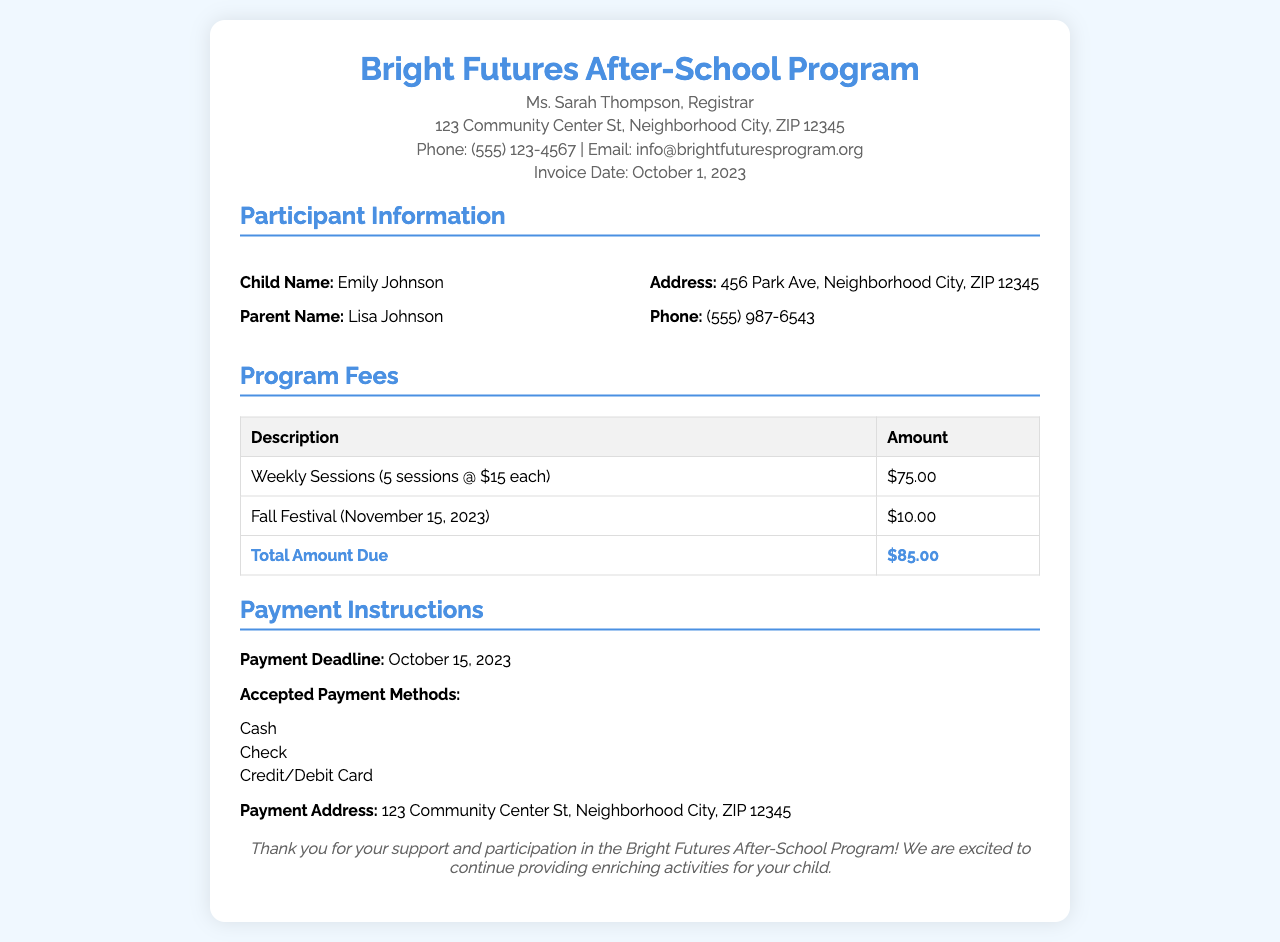what is the total amount due? The total amount due is provided in the invoice, which combines the fees for weekly sessions and special events.
Answer: $85.00 who is the registrar of the program? The invoice mentions the name of the registrar responsible for the program.
Answer: Ms. Sarah Thompson how many weekly sessions are included? The invoice states the number of weekly sessions charged in the fee breakdown.
Answer: 5 sessions what is the fee for one weekly session? The invoice lists the fee associated with a single weekly session.
Answer: $15 each when is the payment deadline? The payment deadline for settling the invoice is specified in the document.
Answer: October 15, 2023 what special event is included in the fees? The document specifies a special event mentioned under program fees.
Answer: Fall Festival how much is the fee for the Fall Festival? The cost listed for attending the Fall Festival event details is noted in the fees section.
Answer: $10.00 what are the accepted payment methods? The invoice details the methods of payment that are acceptable for this program.
Answer: Cash, Check, Credit/Debit Card 